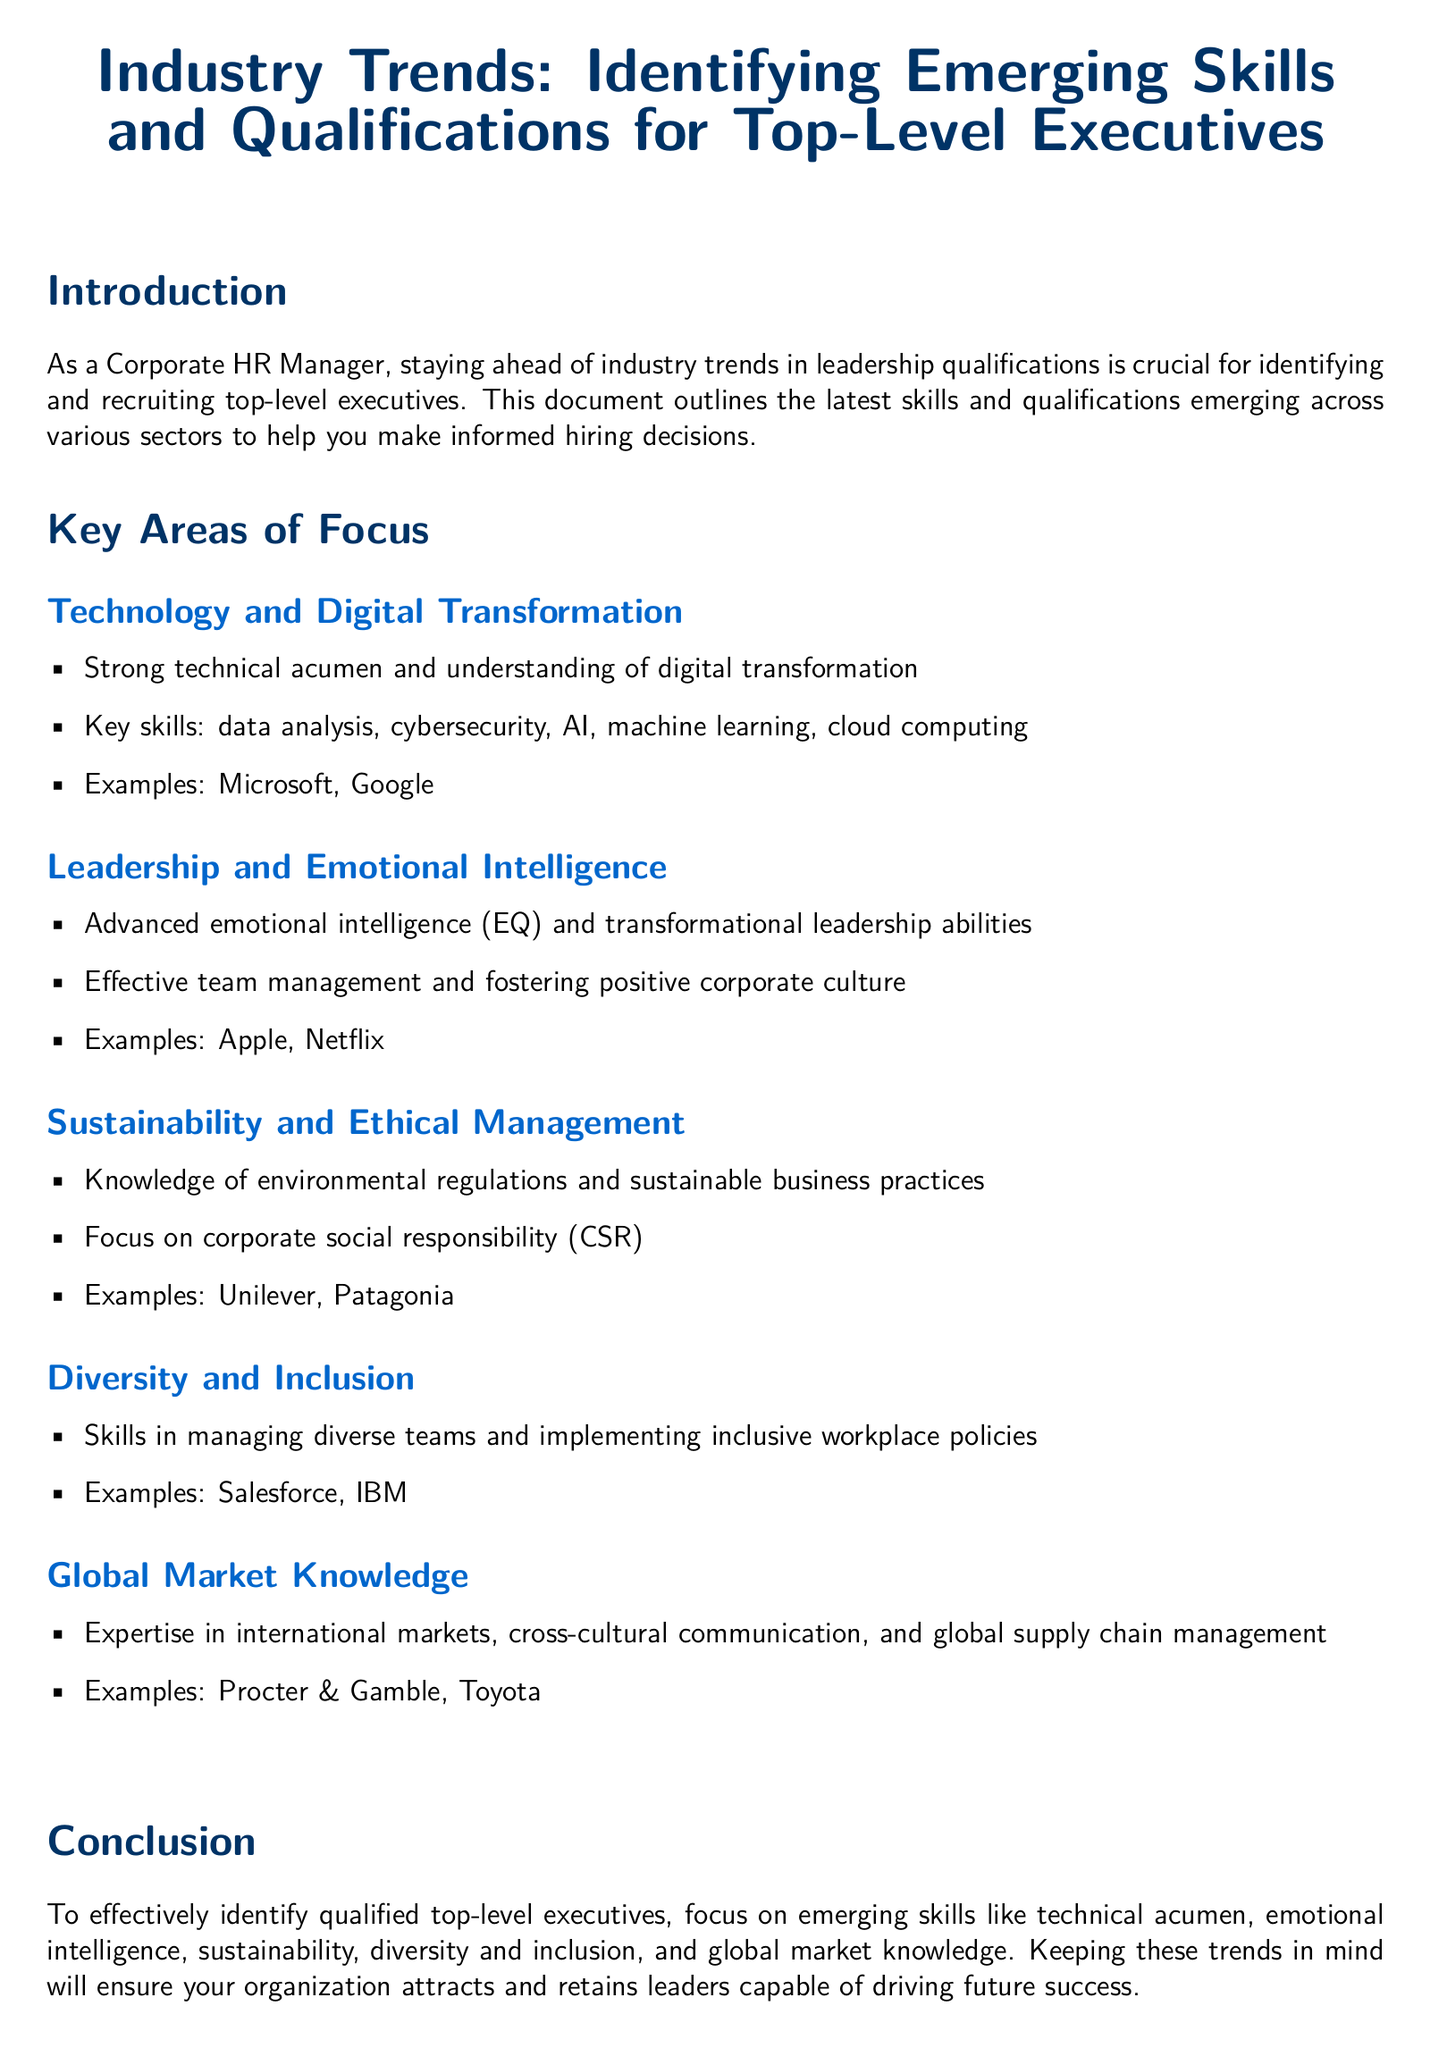What is the main focus of the document? The document focuses on identifying emerging skills and qualifications for top-level executives.
Answer: Emerging skills and qualifications for top-level executives What are the key skills mentioned under Technology and Digital Transformation? The key skills listed include data analysis, cybersecurity, AI, machine learning, and cloud computing.
Answer: Data analysis, cybersecurity, AI, machine learning, cloud computing Name one company that emphasizes Emotional Intelligence. The document mentions Apple as an example of a company valuing emotional intelligence in leadership.
Answer: Apple What area of focus requires knowledge of environmental regulations? The section that addresses sustainable business practices requires knowledge of environmental regulations.
Answer: Sustainability and Ethical Management Which two companies are cited as examples in the Diversity and Inclusion section? Salesforce and IBM are the companies mentioned in the context of managing diverse teams.
Answer: Salesforce, IBM How does the document suggest focusing on leadership qualities? It emphasizes on advanced emotional intelligence and transformational leadership abilities for effective team management.
Answer: Advanced emotional intelligence and transformational leadership abilities What is noted as essential for global market expertise? The document highlights cross-cultural communication as essential for expertise in international markets.
Answer: Cross-cultural communication List one area of expertise needed for top-level executives according to the conclusion. The conclusion mentions technical acumen as one of the emerging skills needed for executives.
Answer: Technical acumen 